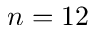<formula> <loc_0><loc_0><loc_500><loc_500>n = 1 2</formula> 